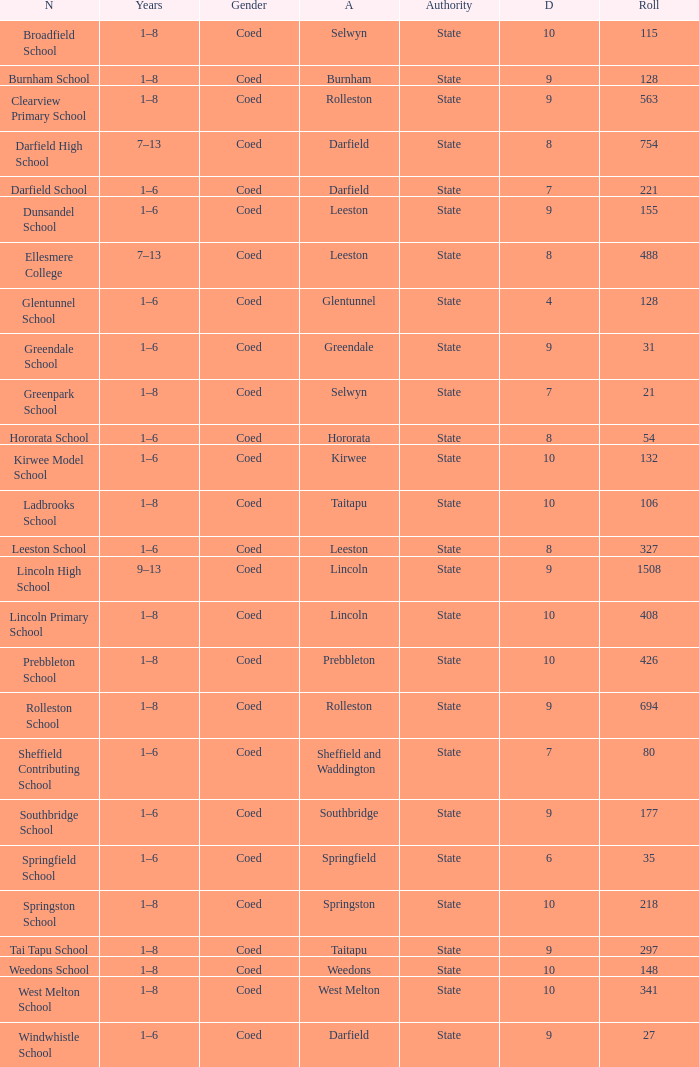How many deciles have Years of 9–13? 1.0. 